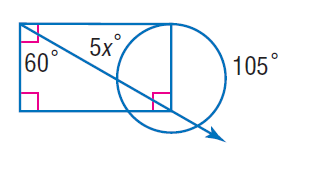Answer the mathemtical geometry problem and directly provide the correct option letter.
Question: Find x. Assume that any segment that appears to be tangent is tangent.
Choices: A: 9 B: 45 C: 60 D: 105 A 